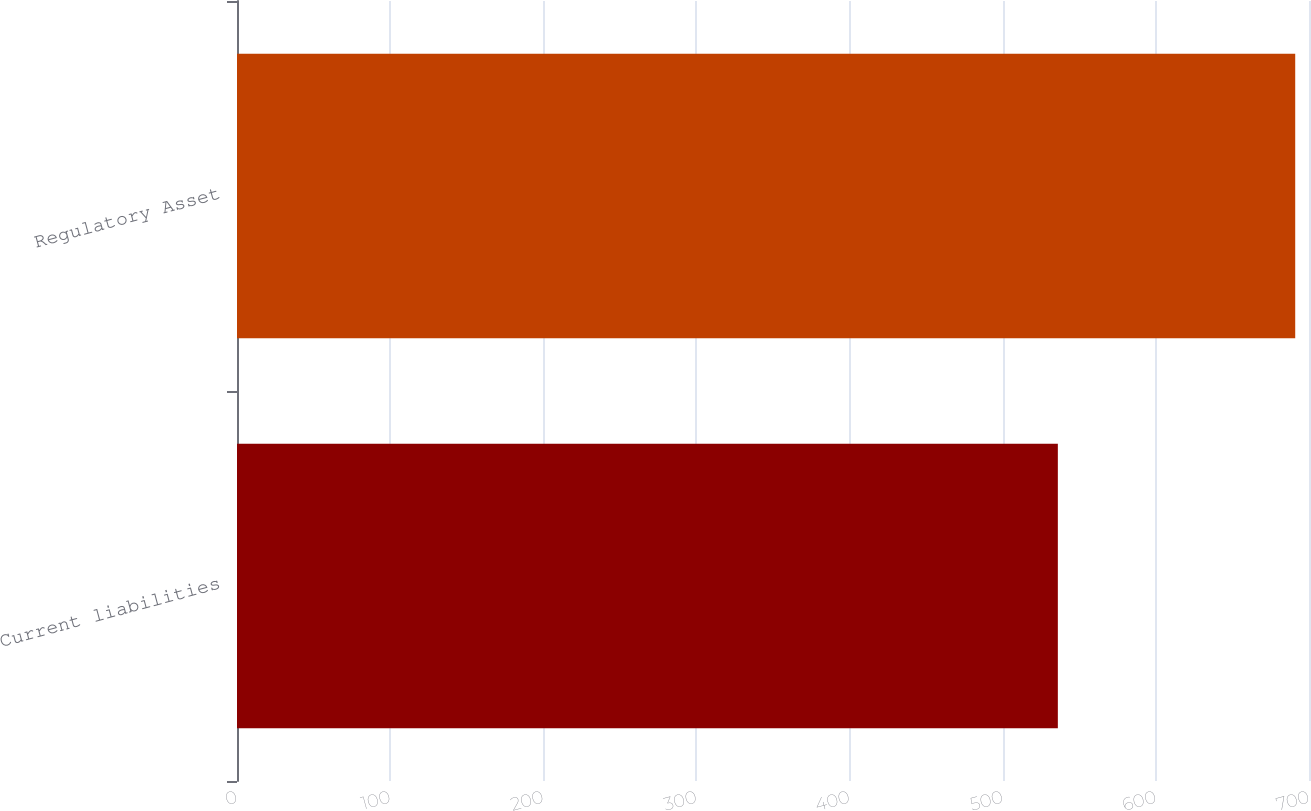Convert chart. <chart><loc_0><loc_0><loc_500><loc_500><bar_chart><fcel>Current liabilities<fcel>Regulatory Asset<nl><fcel>536<fcel>691<nl></chart> 